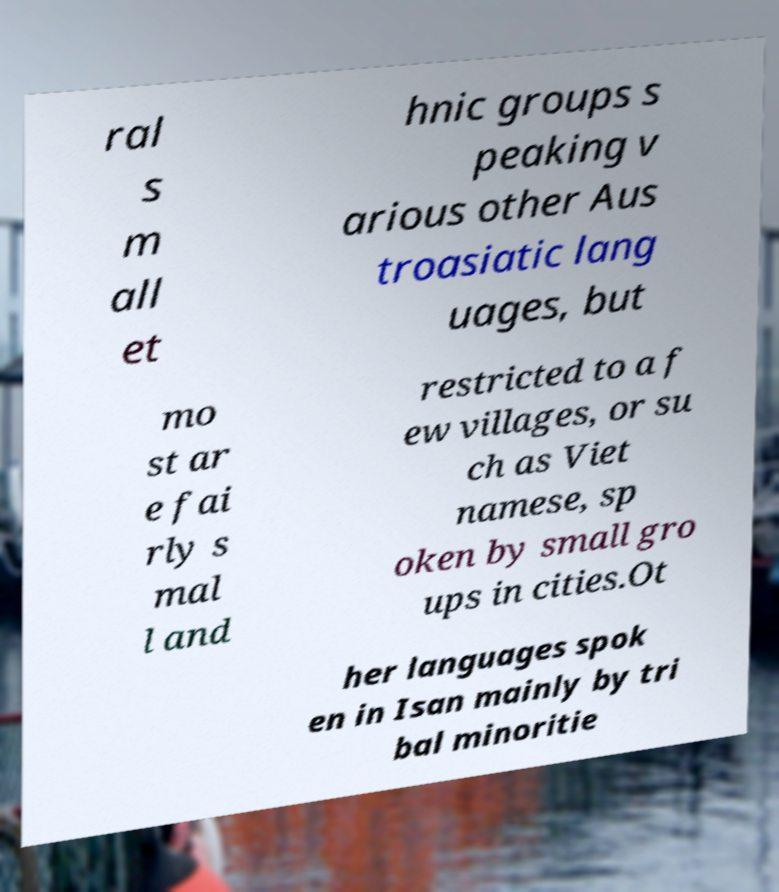Please read and relay the text visible in this image. What does it say? ral s m all et hnic groups s peaking v arious other Aus troasiatic lang uages, but mo st ar e fai rly s mal l and restricted to a f ew villages, or su ch as Viet namese, sp oken by small gro ups in cities.Ot her languages spok en in Isan mainly by tri bal minoritie 